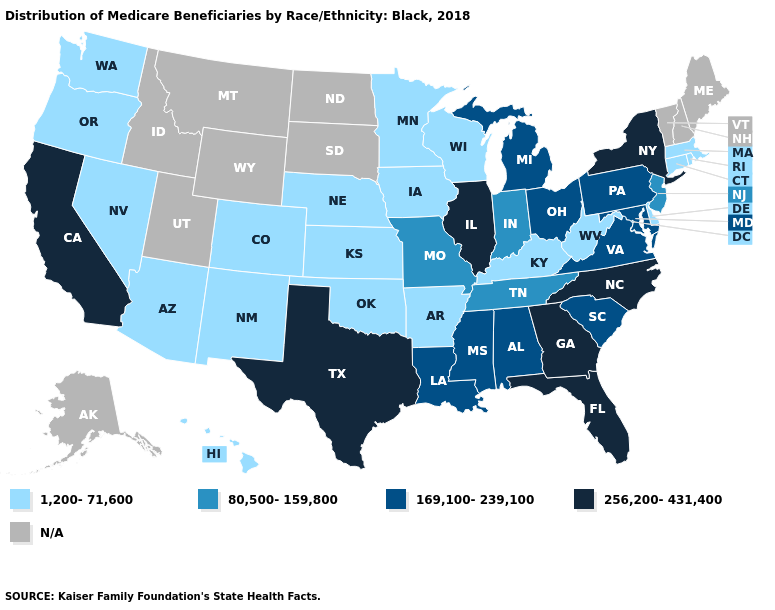What is the lowest value in the Northeast?
Give a very brief answer. 1,200-71,600. What is the highest value in the USA?
Be succinct. 256,200-431,400. Name the states that have a value in the range 80,500-159,800?
Write a very short answer. Indiana, Missouri, New Jersey, Tennessee. Among the states that border Delaware , which have the highest value?
Concise answer only. Maryland, Pennsylvania. Does Georgia have the highest value in the USA?
Answer briefly. Yes. Which states have the highest value in the USA?
Answer briefly. California, Florida, Georgia, Illinois, New York, North Carolina, Texas. Among the states that border Iowa , which have the lowest value?
Concise answer only. Minnesota, Nebraska, Wisconsin. Is the legend a continuous bar?
Answer briefly. No. How many symbols are there in the legend?
Write a very short answer. 5. What is the lowest value in the MidWest?
Give a very brief answer. 1,200-71,600. Name the states that have a value in the range 1,200-71,600?
Short answer required. Arizona, Arkansas, Colorado, Connecticut, Delaware, Hawaii, Iowa, Kansas, Kentucky, Massachusetts, Minnesota, Nebraska, Nevada, New Mexico, Oklahoma, Oregon, Rhode Island, Washington, West Virginia, Wisconsin. Does the map have missing data?
Keep it brief. Yes. Name the states that have a value in the range 80,500-159,800?
Give a very brief answer. Indiana, Missouri, New Jersey, Tennessee. Name the states that have a value in the range 80,500-159,800?
Answer briefly. Indiana, Missouri, New Jersey, Tennessee. 